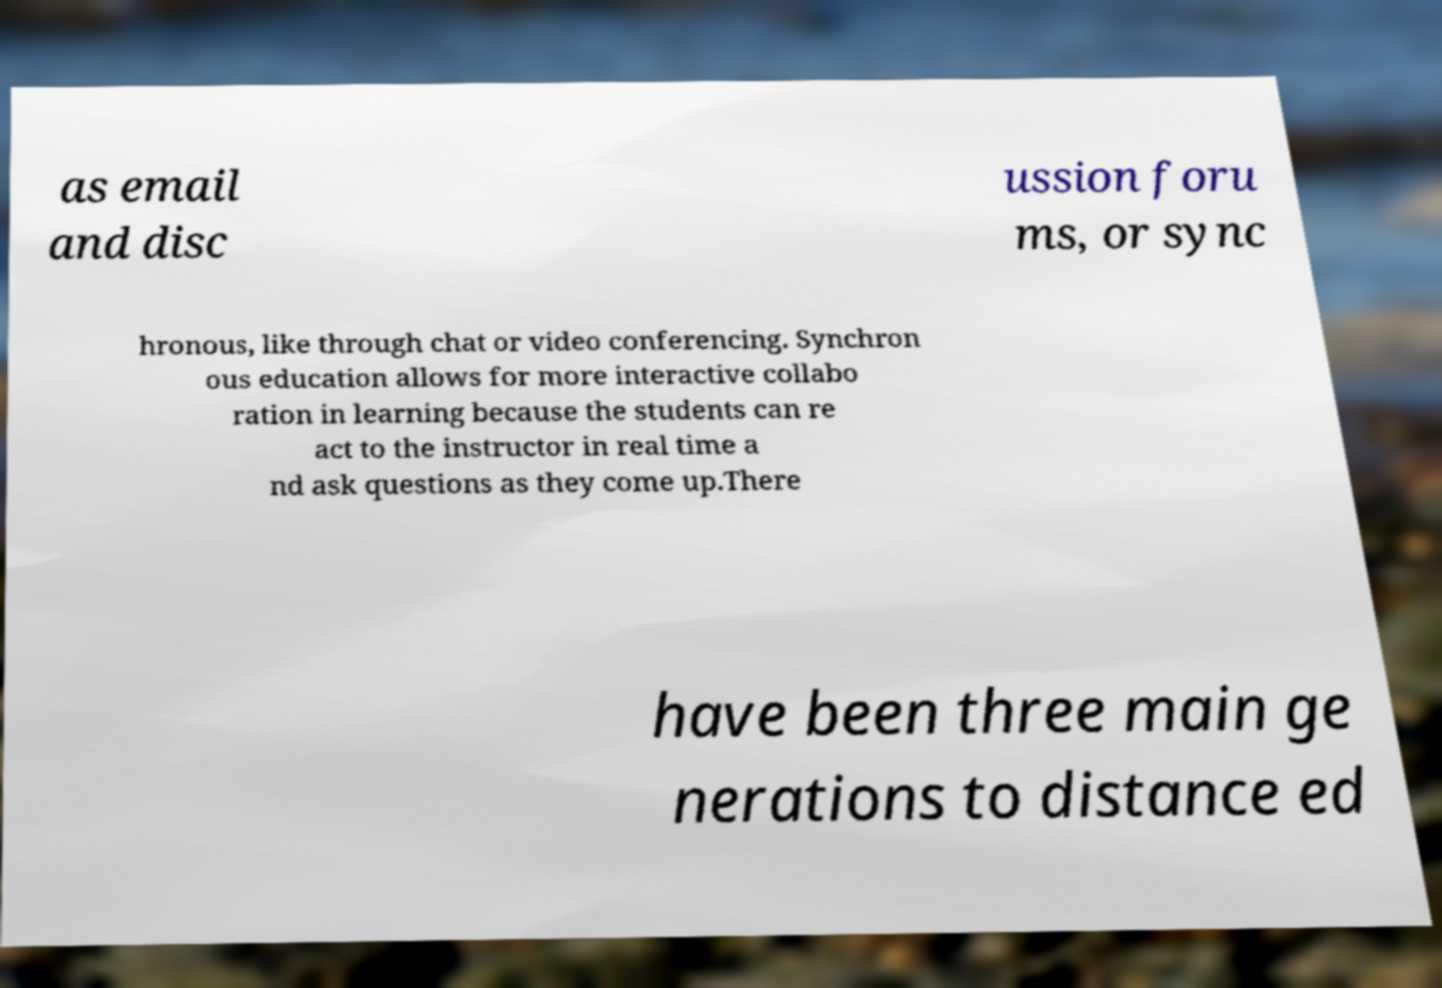Could you extract and type out the text from this image? as email and disc ussion foru ms, or sync hronous, like through chat or video conferencing. Synchron ous education allows for more interactive collabo ration in learning because the students can re act to the instructor in real time a nd ask questions as they come up.There have been three main ge nerations to distance ed 